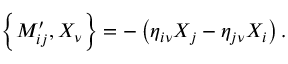<formula> <loc_0><loc_0><loc_500><loc_500>\left \{ M _ { i j } ^ { \prime } , X _ { \nu } \right \} = - \left ( \eta _ { i \nu } X _ { j } - \eta _ { j \nu } X _ { i } \right ) .</formula> 